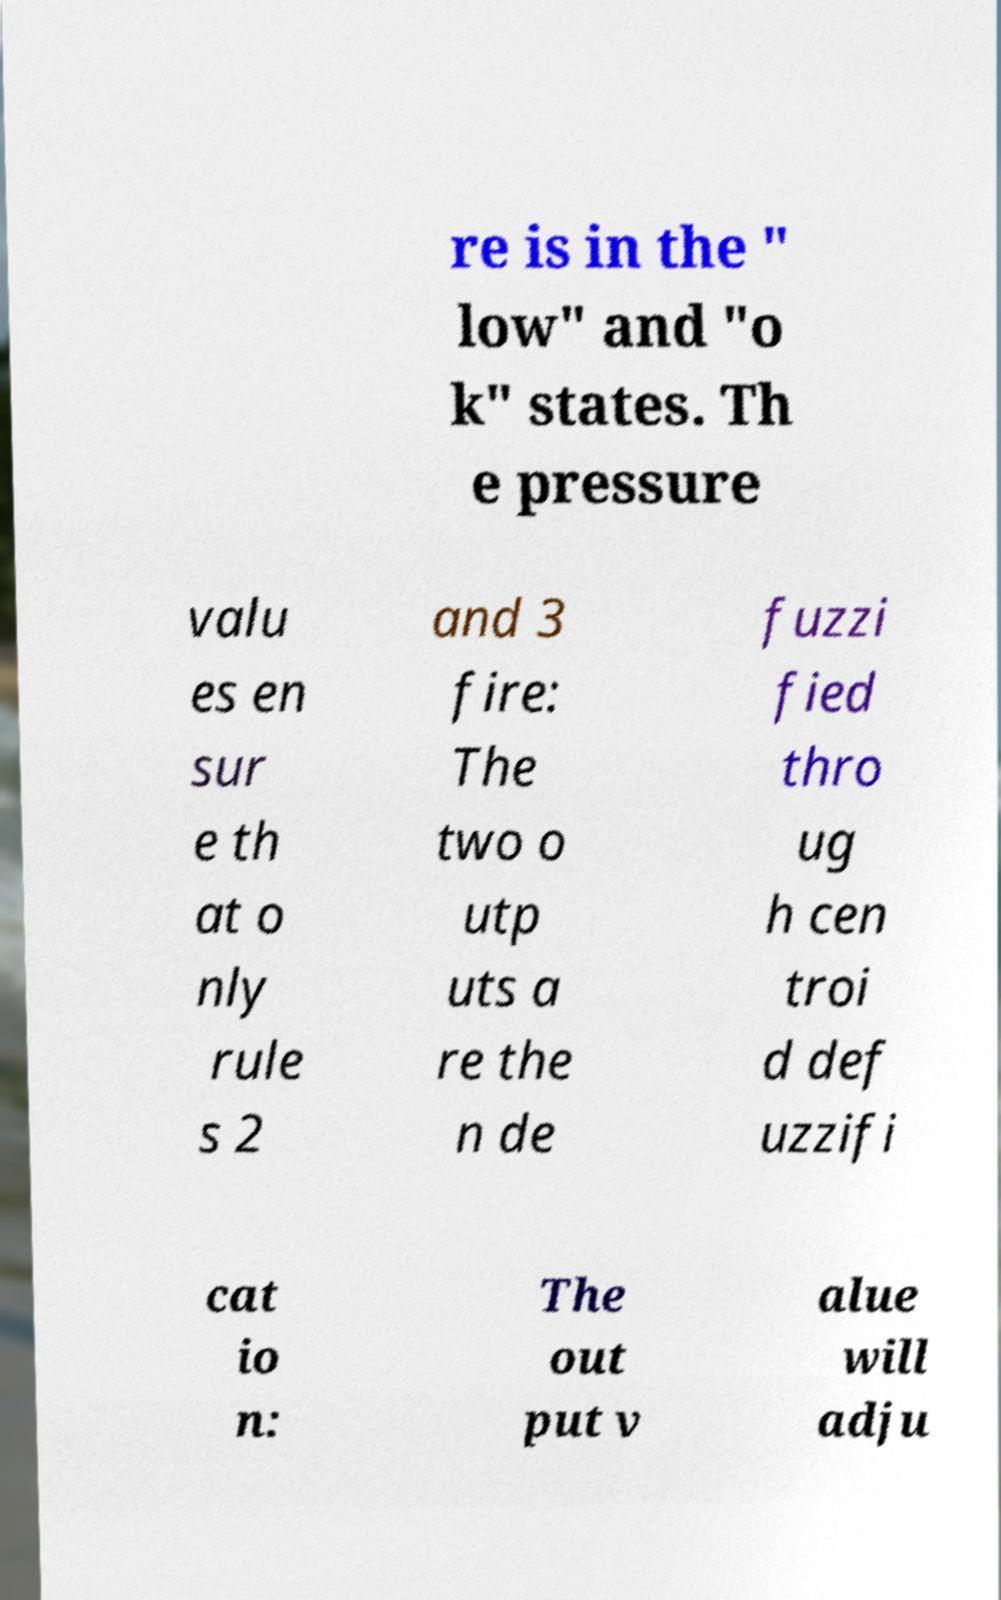Can you accurately transcribe the text from the provided image for me? re is in the " low" and "o k" states. Th e pressure valu es en sur e th at o nly rule s 2 and 3 fire: The two o utp uts a re the n de fuzzi fied thro ug h cen troi d def uzzifi cat io n: The out put v alue will adju 